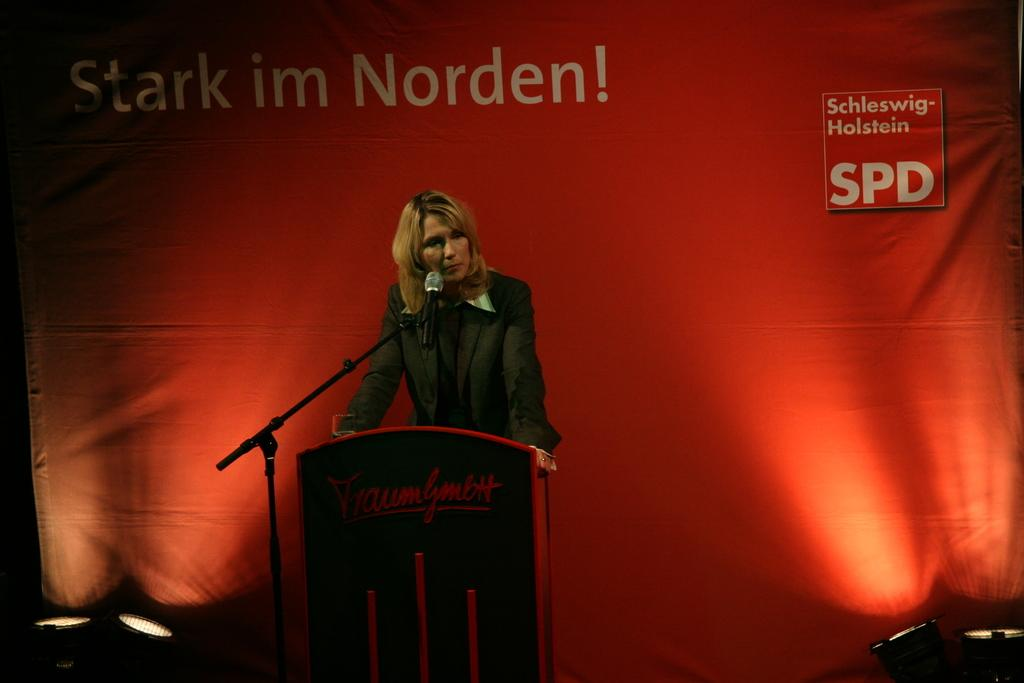What is the person in the image doing near the podium? The person is standing near a podium in the image. What equipment is visible in the image for amplifying sound? There is a microphone with a microphone stand in the image. What can be seen in the background of the image that might indicate a specific event or location? There are focus lights and a banner in the background of the image. What type of rake is being used to maintain the cemetery in the image? There is no cemetery or rake present in the image. What organization is hosting the event in the image? The image does not provide information about the organization hosting the event. 